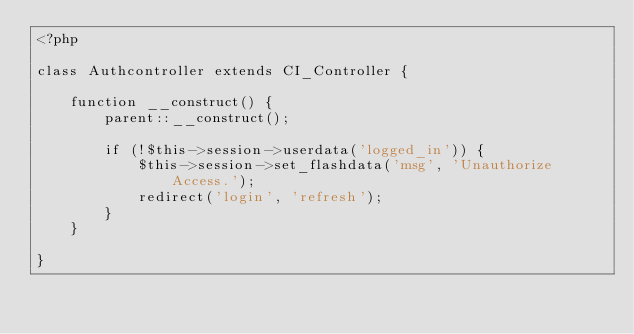Convert code to text. <code><loc_0><loc_0><loc_500><loc_500><_PHP_><?php

class Authcontroller extends CI_Controller {

    function __construct() {
        parent::__construct();
        
        if (!$this->session->userdata('logged_in')) {
            $this->session->set_flashdata('msg', 'Unauthorize Access.');
            redirect('login', 'refresh');
        }
    }

}
</code> 